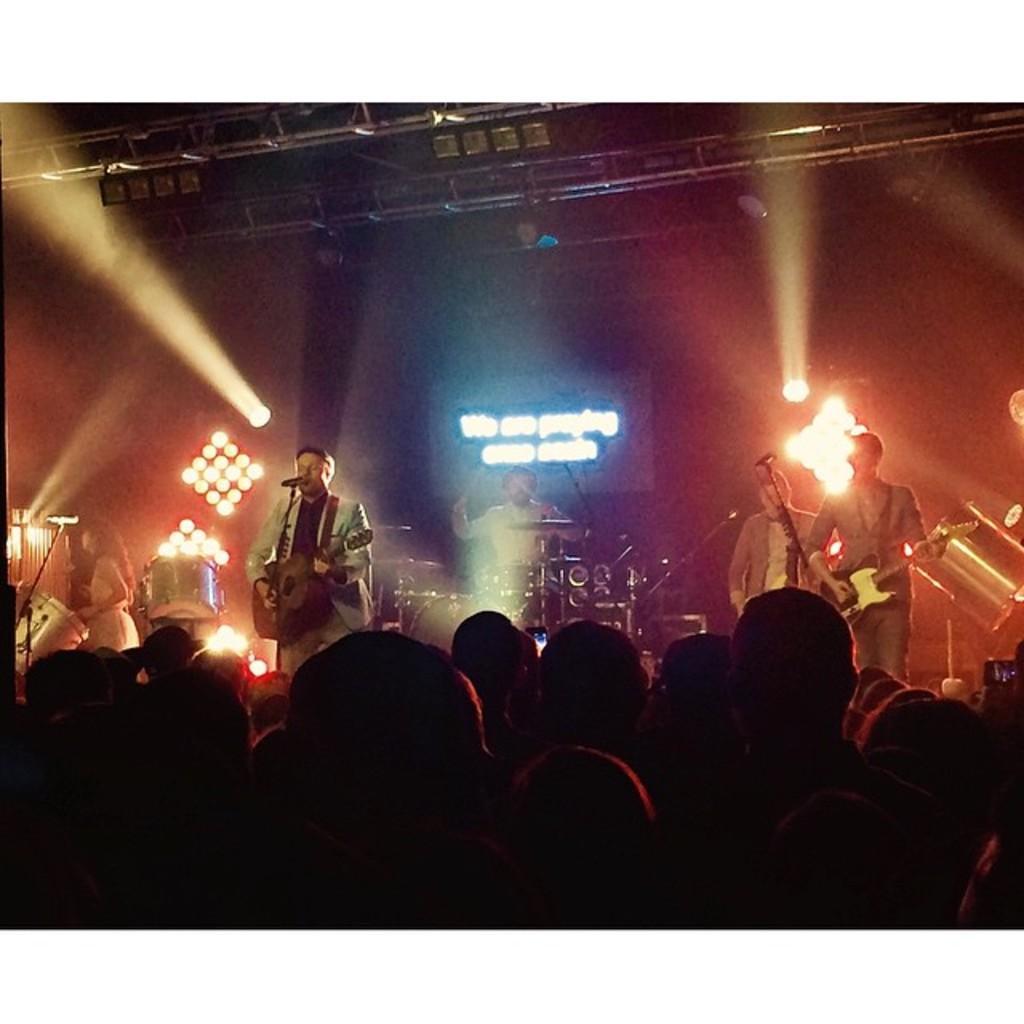In one or two sentences, can you explain what this image depicts? Front these are audience. On stage these two persons are playing guitar and this man is singing in-front of mic. On top there are focusing lights. Far a person is playing this musical instruments with sticks. This woman is playing this musical drum. 